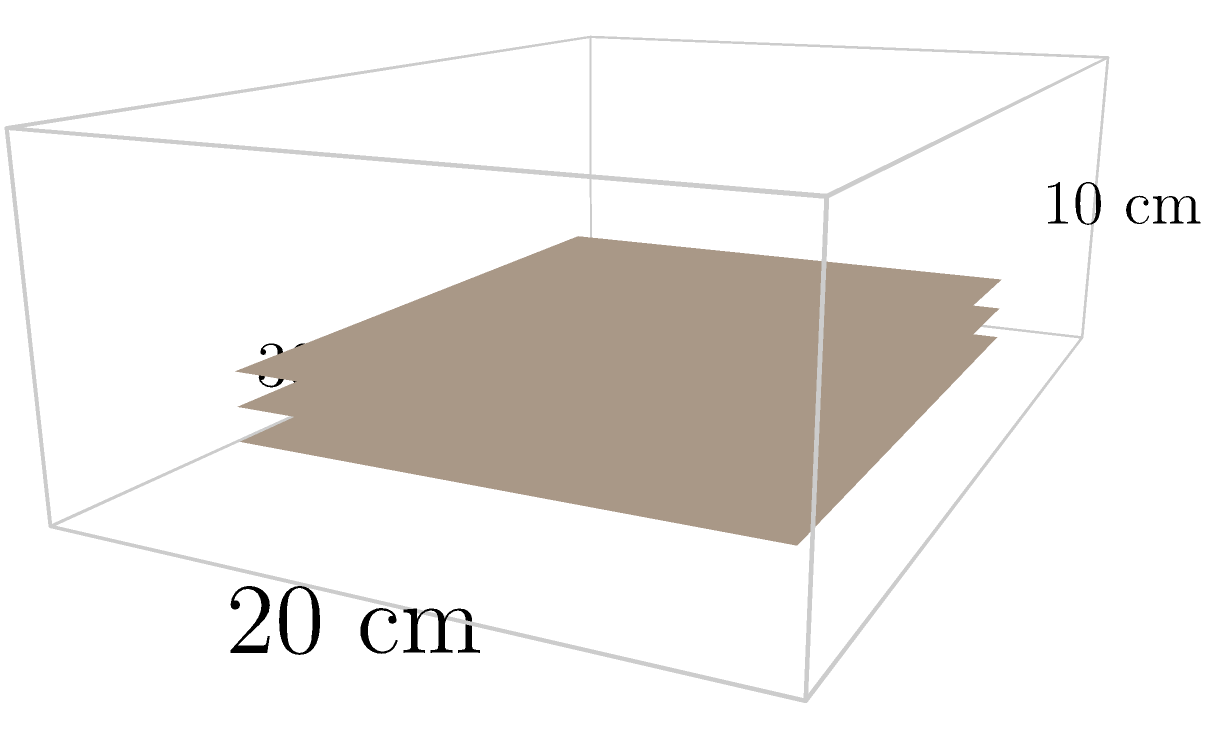You need to conceal three sets of sensitive documents, each measuring 20 cm × 16 cm × 0.5 cm. What are the minimum internal dimensions (length × width × height) of a briefcase that can accommodate these documents while allowing for an additional 1 cm of space on each side for easy retrieval? To determine the minimum internal dimensions of the briefcase, we need to consider the size of the documents and the additional space required:

1. Length:
   - Document length: 20 cm
   - Additional space: 1 cm on each side
   - Total length: $20 + 1 + 1 = 22$ cm

2. Width:
   - Document width: 16 cm
   - Additional space: 1 cm on each side
   - Total width: $16 + 1 + 1 = 18$ cm

3. Height:
   - Document thickness: 0.5 cm
   - Number of document sets: 3
   - Total document height: $0.5 \times 3 = 1.5$ cm
   - Additional space: 1 cm on top and bottom
   - Total height: $1.5 + 1 + 1 = 3.5$ cm

Therefore, the minimum internal dimensions of the briefcase should be 22 cm × 18 cm × 3.5 cm.
Answer: 22 cm × 18 cm × 3.5 cm 